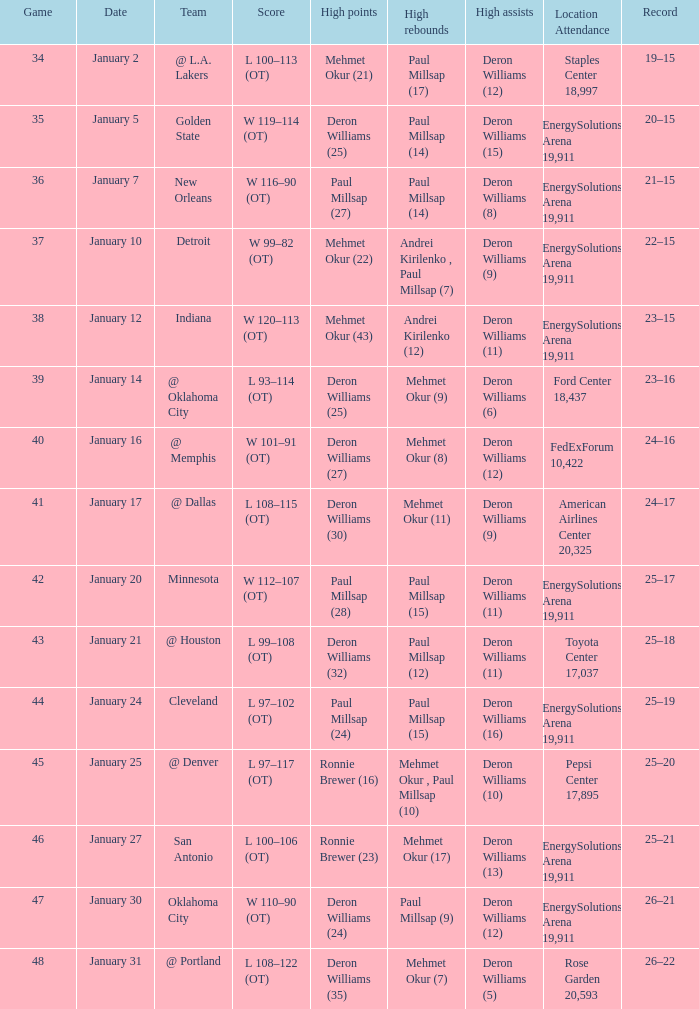What was the score of Game 48? L 108–122 (OT). 